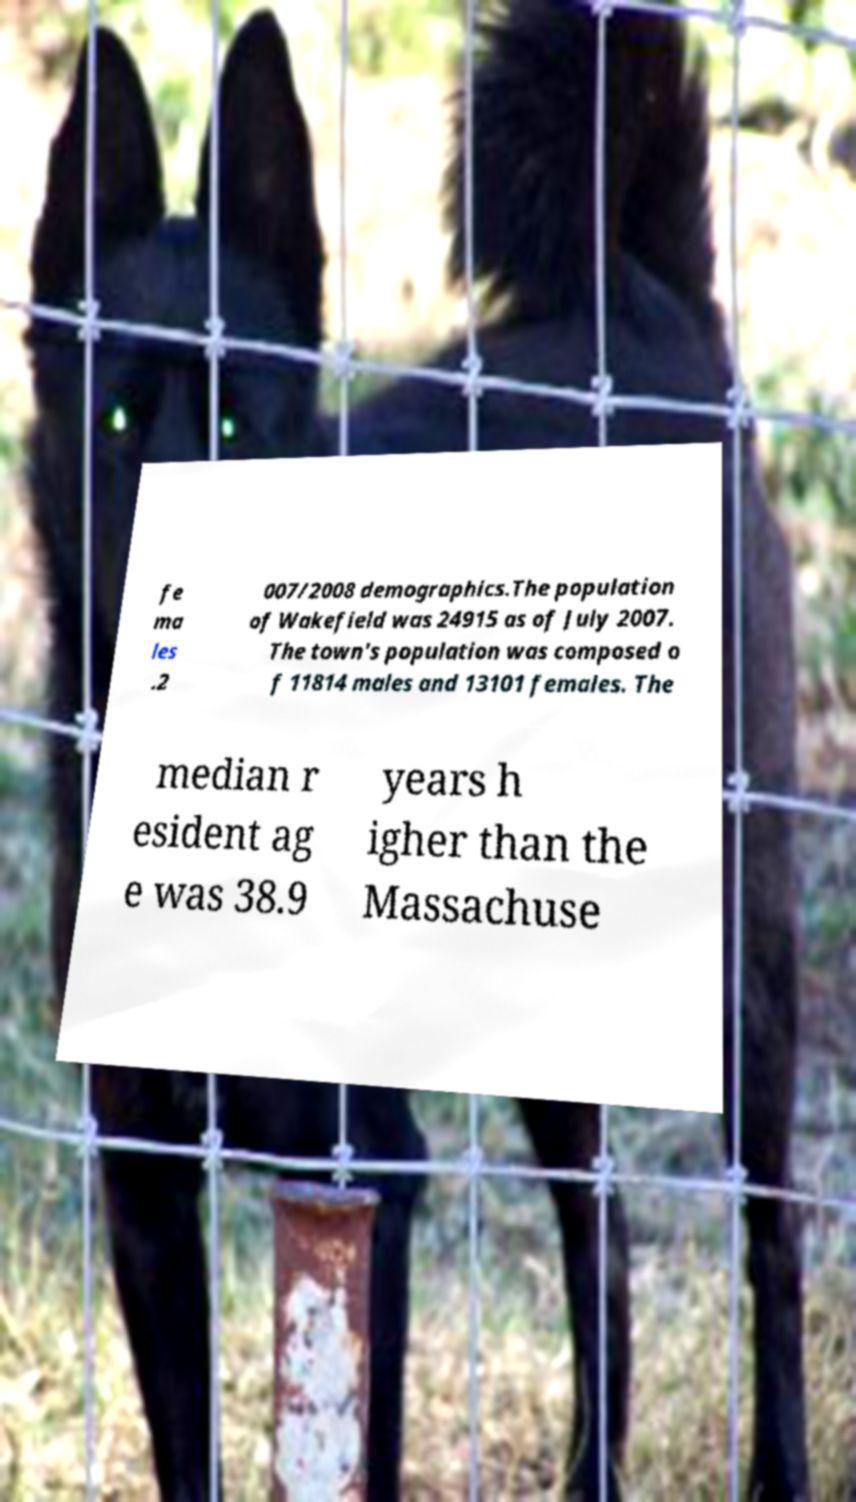Could you extract and type out the text from this image? fe ma les .2 007/2008 demographics.The population of Wakefield was 24915 as of July 2007. The town's population was composed o f 11814 males and 13101 females. The median r esident ag e was 38.9 years h igher than the Massachuse 